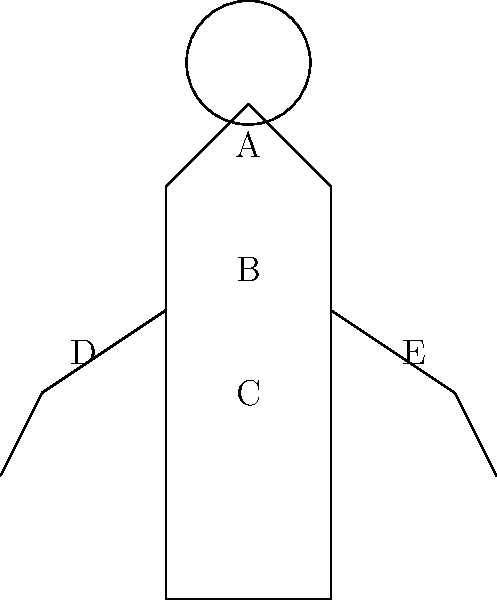As a therapist helping young adults cope with mental health issues, you're working on emotional awareness. Match the following emotions to the areas on the body diagram where they are commonly felt:

1. Anxiety
2. Anger
3. Sadness
4. Shame
5. Joy

Which area (A, B, C, D, or E) is most commonly associated with each emotion? Step 1: Understand the connection between emotions and physical sensations.
- Different emotions often manifest as physical sensations in specific areas of the body.

Step 2: Analyze each emotion and its common physical manifestation:
1. Anxiety: Often felt as tightness or butterflies in the stomach (Area C)
2. Anger: Typically experienced as heat or tension in the chest and arms (Areas B, D, and E)
3. Sadness: Usually felt as heaviness in the chest or a lump in the throat (Area B)
4. Shame: Commonly associated with a sinking feeling in the stomach or gut (Area C)
5. Joy: Often experienced as warmth or lightness in the chest and face (Areas A and B)

Step 3: Match each emotion to the most prominent area:
1. Anxiety → C (stomach area)
2. Anger → B (chest area, as it's central to the experience)
3. Sadness → B (chest area)
4. Shame → C (stomach/gut area)
5. Joy → B (chest area, as it's central to the experience)

This exercise helps young adults identify and localize their emotional experiences, which is crucial for developing emotional awareness and regulation skills.
Answer: 1-C, 2-B, 3-B, 4-C, 5-B 